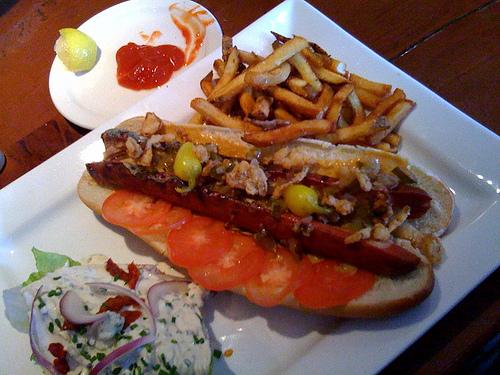Is the hotdog well seasoned?
Answer briefly. Yes. Is the meat raw?
Answer briefly. No. What color is the plate?
Quick response, please. White. Is this breakfast food?
Give a very brief answer. No. Is there ketchup?
Concise answer only. Yes. 